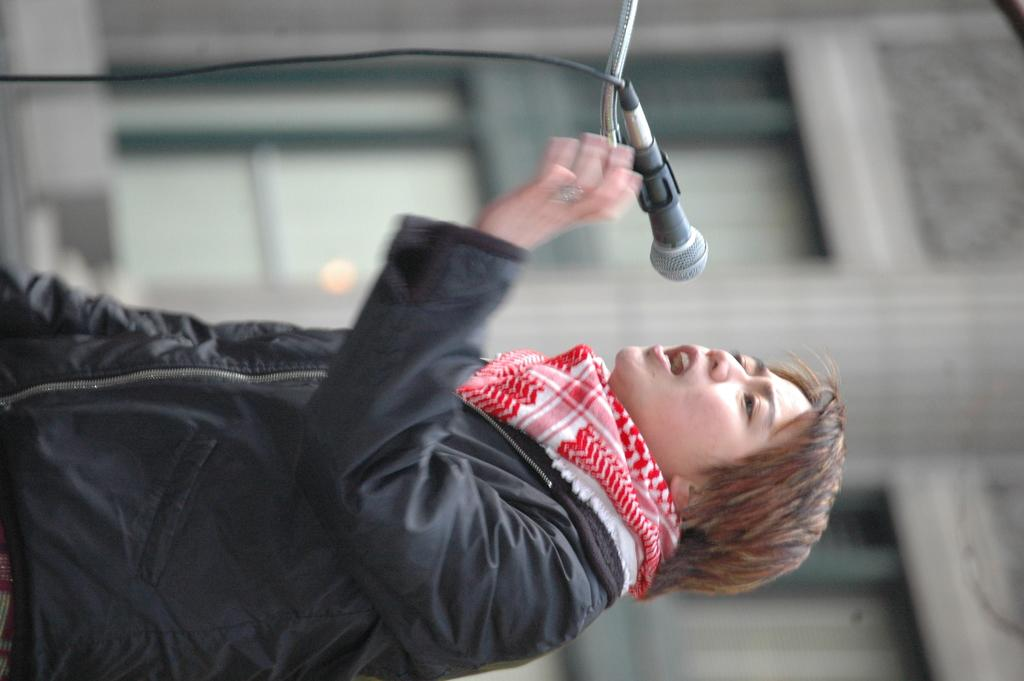How is the image oriented? The image is tilted. What is the person in the image doing? The person is standing and talking. What object is in front of the person? There is a microphone in front of the person. Can you describe the background of the image? The background is blurry. Are there any bears visible in the wilderness behind the person in the image? There are no bears or wilderness present in the image; it features a person talking with a microphone in front of them. 